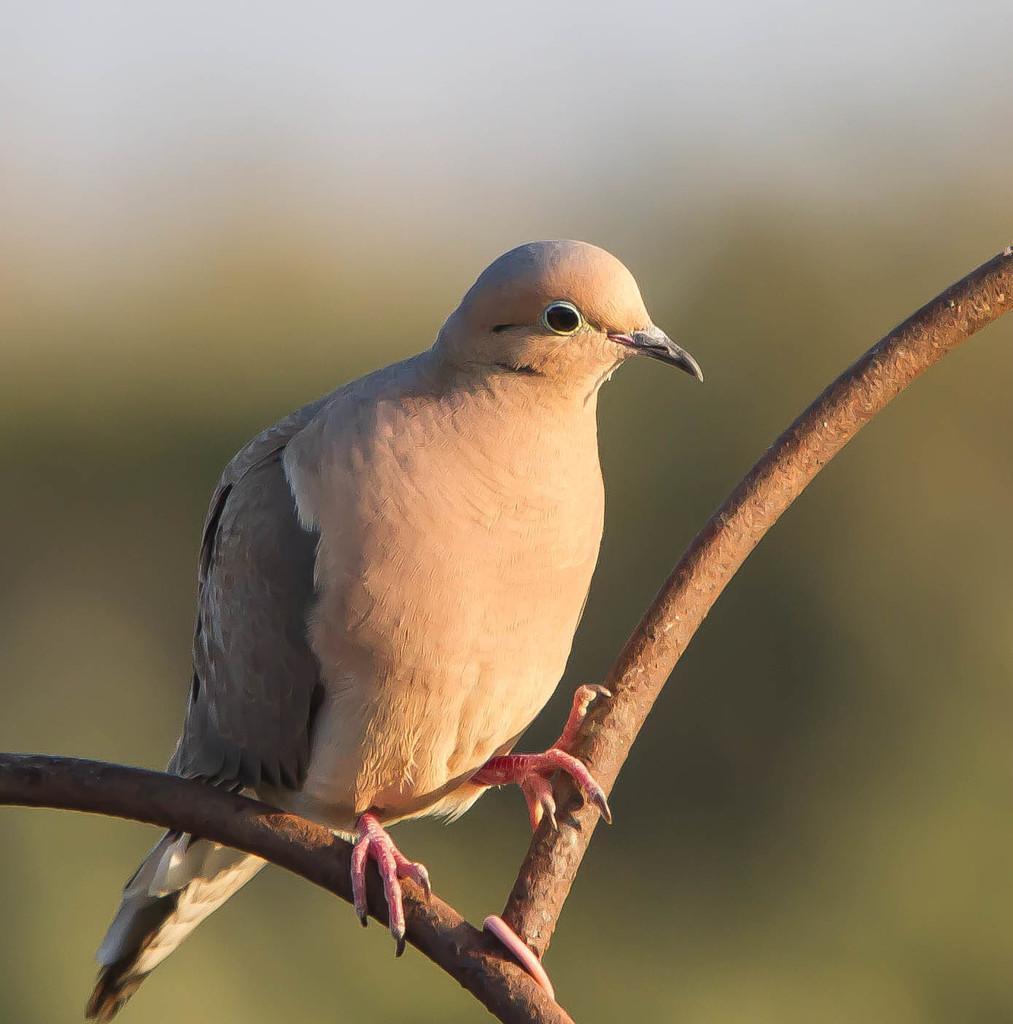Please provide a concise description of this image. In the image there is a bird standing on a branch and the background of the bird is blue. 